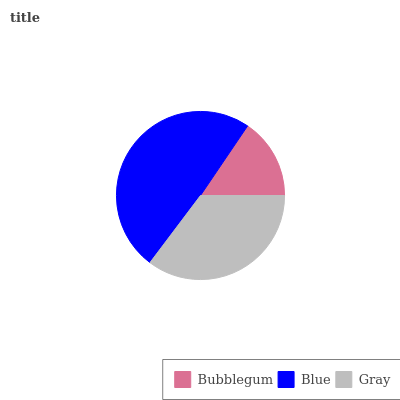Is Bubblegum the minimum?
Answer yes or no. Yes. Is Blue the maximum?
Answer yes or no. Yes. Is Gray the minimum?
Answer yes or no. No. Is Gray the maximum?
Answer yes or no. No. Is Blue greater than Gray?
Answer yes or no. Yes. Is Gray less than Blue?
Answer yes or no. Yes. Is Gray greater than Blue?
Answer yes or no. No. Is Blue less than Gray?
Answer yes or no. No. Is Gray the high median?
Answer yes or no. Yes. Is Gray the low median?
Answer yes or no. Yes. Is Blue the high median?
Answer yes or no. No. Is Blue the low median?
Answer yes or no. No. 